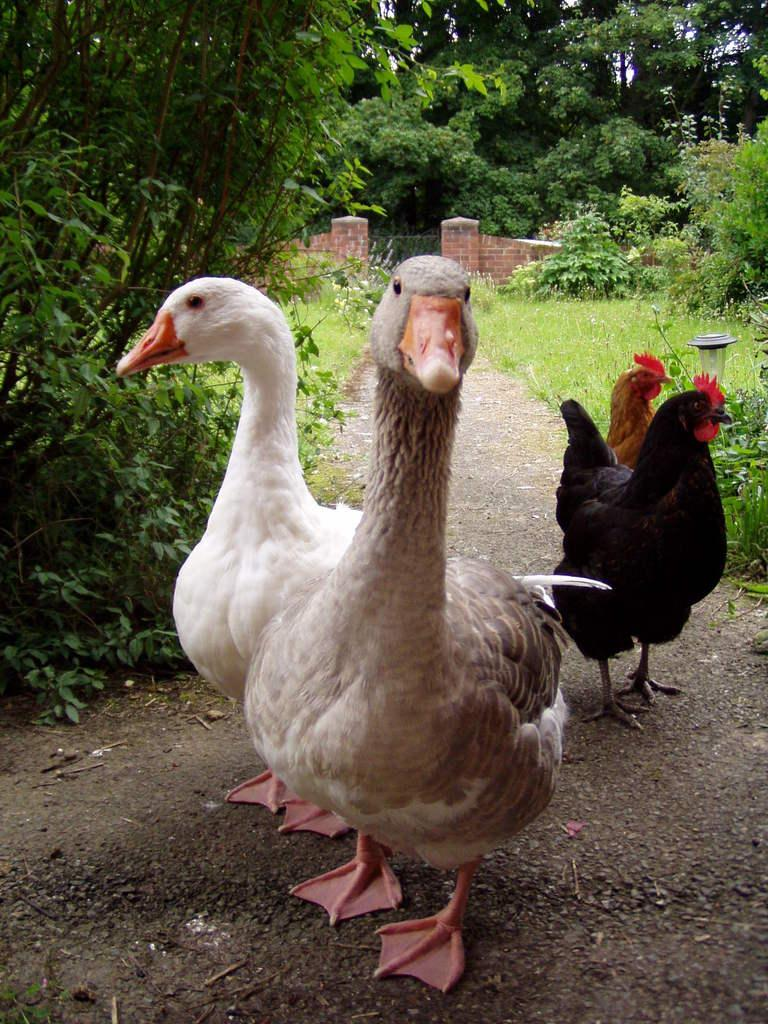What type of animals can be seen in the image? There are hens and white color ducks in the image. What type of vegetation is visible in the image? There is grass, plants, and trees in the image. What is the background of the image? There is a wall in the image. What type of plane can be seen flying in the image? There is no plane visible in the image. What is the spoon used for in the image? There is no spoon present in the image. 